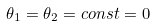Convert formula to latex. <formula><loc_0><loc_0><loc_500><loc_500>\theta _ { 1 } = \theta _ { 2 } = c o n s t = 0</formula> 